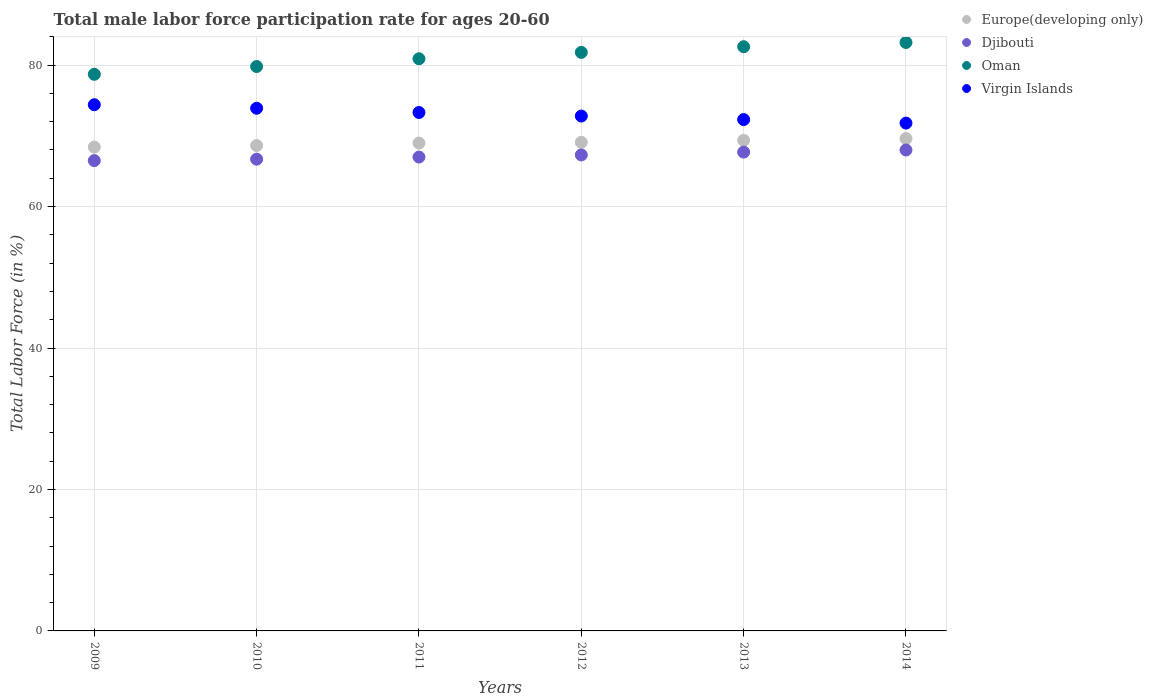What is the male labor force participation rate in Europe(developing only) in 2009?
Your answer should be compact. 68.41. Across all years, what is the minimum male labor force participation rate in Virgin Islands?
Keep it short and to the point. 71.8. What is the total male labor force participation rate in Virgin Islands in the graph?
Offer a very short reply. 438.5. What is the difference between the male labor force participation rate in Europe(developing only) in 2011 and that in 2014?
Give a very brief answer. -0.63. What is the difference between the male labor force participation rate in Virgin Islands in 2011 and the male labor force participation rate in Europe(developing only) in 2009?
Ensure brevity in your answer.  4.89. What is the average male labor force participation rate in Virgin Islands per year?
Provide a short and direct response. 73.08. In the year 2011, what is the difference between the male labor force participation rate in Virgin Islands and male labor force participation rate in Europe(developing only)?
Your answer should be compact. 4.32. In how many years, is the male labor force participation rate in Oman greater than 36 %?
Provide a succinct answer. 6. What is the ratio of the male labor force participation rate in Europe(developing only) in 2012 to that in 2014?
Your answer should be very brief. 0.99. Is the difference between the male labor force participation rate in Virgin Islands in 2012 and 2014 greater than the difference between the male labor force participation rate in Europe(developing only) in 2012 and 2014?
Provide a succinct answer. Yes. What is the difference between the highest and the second highest male labor force participation rate in Europe(developing only)?
Your answer should be very brief. 0.25. Does the male labor force participation rate in Virgin Islands monotonically increase over the years?
Ensure brevity in your answer.  No. Is the male labor force participation rate in Europe(developing only) strictly less than the male labor force participation rate in Oman over the years?
Give a very brief answer. Yes. What is the difference between two consecutive major ticks on the Y-axis?
Ensure brevity in your answer.  20. Are the values on the major ticks of Y-axis written in scientific E-notation?
Provide a succinct answer. No. Does the graph contain any zero values?
Your response must be concise. No. Does the graph contain grids?
Keep it short and to the point. Yes. Where does the legend appear in the graph?
Your answer should be compact. Top right. What is the title of the graph?
Ensure brevity in your answer.  Total male labor force participation rate for ages 20-60. What is the label or title of the X-axis?
Your answer should be very brief. Years. What is the Total Labor Force (in %) of Europe(developing only) in 2009?
Keep it short and to the point. 68.41. What is the Total Labor Force (in %) in Djibouti in 2009?
Give a very brief answer. 66.5. What is the Total Labor Force (in %) in Oman in 2009?
Give a very brief answer. 78.7. What is the Total Labor Force (in %) of Virgin Islands in 2009?
Provide a succinct answer. 74.4. What is the Total Labor Force (in %) in Europe(developing only) in 2010?
Provide a short and direct response. 68.63. What is the Total Labor Force (in %) in Djibouti in 2010?
Make the answer very short. 66.7. What is the Total Labor Force (in %) of Oman in 2010?
Your answer should be compact. 79.8. What is the Total Labor Force (in %) of Virgin Islands in 2010?
Your response must be concise. 73.9. What is the Total Labor Force (in %) of Europe(developing only) in 2011?
Your response must be concise. 68.98. What is the Total Labor Force (in %) in Oman in 2011?
Provide a short and direct response. 80.9. What is the Total Labor Force (in %) of Virgin Islands in 2011?
Offer a very short reply. 73.3. What is the Total Labor Force (in %) of Europe(developing only) in 2012?
Provide a succinct answer. 69.09. What is the Total Labor Force (in %) of Djibouti in 2012?
Provide a succinct answer. 67.3. What is the Total Labor Force (in %) of Oman in 2012?
Ensure brevity in your answer.  81.8. What is the Total Labor Force (in %) in Virgin Islands in 2012?
Your answer should be compact. 72.8. What is the Total Labor Force (in %) in Europe(developing only) in 2013?
Offer a terse response. 69.37. What is the Total Labor Force (in %) in Djibouti in 2013?
Offer a terse response. 67.7. What is the Total Labor Force (in %) of Oman in 2013?
Offer a terse response. 82.6. What is the Total Labor Force (in %) in Virgin Islands in 2013?
Offer a terse response. 72.3. What is the Total Labor Force (in %) of Europe(developing only) in 2014?
Make the answer very short. 69.61. What is the Total Labor Force (in %) of Djibouti in 2014?
Offer a terse response. 68. What is the Total Labor Force (in %) in Oman in 2014?
Give a very brief answer. 83.2. What is the Total Labor Force (in %) of Virgin Islands in 2014?
Provide a succinct answer. 71.8. Across all years, what is the maximum Total Labor Force (in %) in Europe(developing only)?
Your answer should be compact. 69.61. Across all years, what is the maximum Total Labor Force (in %) of Djibouti?
Your response must be concise. 68. Across all years, what is the maximum Total Labor Force (in %) of Oman?
Offer a very short reply. 83.2. Across all years, what is the maximum Total Labor Force (in %) in Virgin Islands?
Your response must be concise. 74.4. Across all years, what is the minimum Total Labor Force (in %) of Europe(developing only)?
Offer a very short reply. 68.41. Across all years, what is the minimum Total Labor Force (in %) in Djibouti?
Provide a short and direct response. 66.5. Across all years, what is the minimum Total Labor Force (in %) in Oman?
Give a very brief answer. 78.7. Across all years, what is the minimum Total Labor Force (in %) in Virgin Islands?
Your response must be concise. 71.8. What is the total Total Labor Force (in %) in Europe(developing only) in the graph?
Keep it short and to the point. 414.09. What is the total Total Labor Force (in %) of Djibouti in the graph?
Offer a very short reply. 403.2. What is the total Total Labor Force (in %) in Oman in the graph?
Your answer should be compact. 487. What is the total Total Labor Force (in %) in Virgin Islands in the graph?
Your response must be concise. 438.5. What is the difference between the Total Labor Force (in %) of Europe(developing only) in 2009 and that in 2010?
Provide a succinct answer. -0.22. What is the difference between the Total Labor Force (in %) in Djibouti in 2009 and that in 2010?
Ensure brevity in your answer.  -0.2. What is the difference between the Total Labor Force (in %) in Oman in 2009 and that in 2010?
Provide a succinct answer. -1.1. What is the difference between the Total Labor Force (in %) of Virgin Islands in 2009 and that in 2010?
Your answer should be very brief. 0.5. What is the difference between the Total Labor Force (in %) of Europe(developing only) in 2009 and that in 2011?
Offer a very short reply. -0.57. What is the difference between the Total Labor Force (in %) of Djibouti in 2009 and that in 2011?
Offer a very short reply. -0.5. What is the difference between the Total Labor Force (in %) of Europe(developing only) in 2009 and that in 2012?
Your answer should be very brief. -0.68. What is the difference between the Total Labor Force (in %) of Oman in 2009 and that in 2012?
Offer a very short reply. -3.1. What is the difference between the Total Labor Force (in %) in Virgin Islands in 2009 and that in 2012?
Your response must be concise. 1.6. What is the difference between the Total Labor Force (in %) in Europe(developing only) in 2009 and that in 2013?
Offer a terse response. -0.96. What is the difference between the Total Labor Force (in %) in Virgin Islands in 2009 and that in 2013?
Make the answer very short. 2.1. What is the difference between the Total Labor Force (in %) in Europe(developing only) in 2009 and that in 2014?
Your response must be concise. -1.21. What is the difference between the Total Labor Force (in %) of Djibouti in 2009 and that in 2014?
Ensure brevity in your answer.  -1.5. What is the difference between the Total Labor Force (in %) in Oman in 2009 and that in 2014?
Provide a short and direct response. -4.5. What is the difference between the Total Labor Force (in %) in Virgin Islands in 2009 and that in 2014?
Ensure brevity in your answer.  2.6. What is the difference between the Total Labor Force (in %) in Europe(developing only) in 2010 and that in 2011?
Give a very brief answer. -0.35. What is the difference between the Total Labor Force (in %) in Oman in 2010 and that in 2011?
Provide a succinct answer. -1.1. What is the difference between the Total Labor Force (in %) in Virgin Islands in 2010 and that in 2011?
Ensure brevity in your answer.  0.6. What is the difference between the Total Labor Force (in %) in Europe(developing only) in 2010 and that in 2012?
Make the answer very short. -0.46. What is the difference between the Total Labor Force (in %) in Virgin Islands in 2010 and that in 2012?
Keep it short and to the point. 1.1. What is the difference between the Total Labor Force (in %) of Europe(developing only) in 2010 and that in 2013?
Ensure brevity in your answer.  -0.74. What is the difference between the Total Labor Force (in %) of Djibouti in 2010 and that in 2013?
Your answer should be compact. -1. What is the difference between the Total Labor Force (in %) in Europe(developing only) in 2010 and that in 2014?
Your answer should be very brief. -0.99. What is the difference between the Total Labor Force (in %) of Djibouti in 2010 and that in 2014?
Provide a short and direct response. -1.3. What is the difference between the Total Labor Force (in %) of Europe(developing only) in 2011 and that in 2012?
Keep it short and to the point. -0.1. What is the difference between the Total Labor Force (in %) of Djibouti in 2011 and that in 2012?
Make the answer very short. -0.3. What is the difference between the Total Labor Force (in %) of Europe(developing only) in 2011 and that in 2013?
Make the answer very short. -0.39. What is the difference between the Total Labor Force (in %) in Europe(developing only) in 2011 and that in 2014?
Keep it short and to the point. -0.63. What is the difference between the Total Labor Force (in %) of Oman in 2011 and that in 2014?
Offer a terse response. -2.3. What is the difference between the Total Labor Force (in %) of Virgin Islands in 2011 and that in 2014?
Keep it short and to the point. 1.5. What is the difference between the Total Labor Force (in %) of Europe(developing only) in 2012 and that in 2013?
Give a very brief answer. -0.28. What is the difference between the Total Labor Force (in %) in Djibouti in 2012 and that in 2013?
Offer a very short reply. -0.4. What is the difference between the Total Labor Force (in %) of Oman in 2012 and that in 2013?
Make the answer very short. -0.8. What is the difference between the Total Labor Force (in %) of Europe(developing only) in 2012 and that in 2014?
Make the answer very short. -0.53. What is the difference between the Total Labor Force (in %) in Djibouti in 2012 and that in 2014?
Provide a short and direct response. -0.7. What is the difference between the Total Labor Force (in %) of Europe(developing only) in 2013 and that in 2014?
Provide a short and direct response. -0.25. What is the difference between the Total Labor Force (in %) of Oman in 2013 and that in 2014?
Your answer should be very brief. -0.6. What is the difference between the Total Labor Force (in %) of Virgin Islands in 2013 and that in 2014?
Offer a very short reply. 0.5. What is the difference between the Total Labor Force (in %) of Europe(developing only) in 2009 and the Total Labor Force (in %) of Djibouti in 2010?
Provide a succinct answer. 1.71. What is the difference between the Total Labor Force (in %) in Europe(developing only) in 2009 and the Total Labor Force (in %) in Oman in 2010?
Offer a very short reply. -11.39. What is the difference between the Total Labor Force (in %) in Europe(developing only) in 2009 and the Total Labor Force (in %) in Virgin Islands in 2010?
Make the answer very short. -5.49. What is the difference between the Total Labor Force (in %) of Europe(developing only) in 2009 and the Total Labor Force (in %) of Djibouti in 2011?
Keep it short and to the point. 1.41. What is the difference between the Total Labor Force (in %) in Europe(developing only) in 2009 and the Total Labor Force (in %) in Oman in 2011?
Provide a short and direct response. -12.49. What is the difference between the Total Labor Force (in %) of Europe(developing only) in 2009 and the Total Labor Force (in %) of Virgin Islands in 2011?
Provide a succinct answer. -4.89. What is the difference between the Total Labor Force (in %) of Djibouti in 2009 and the Total Labor Force (in %) of Oman in 2011?
Provide a short and direct response. -14.4. What is the difference between the Total Labor Force (in %) in Djibouti in 2009 and the Total Labor Force (in %) in Virgin Islands in 2011?
Provide a short and direct response. -6.8. What is the difference between the Total Labor Force (in %) of Oman in 2009 and the Total Labor Force (in %) of Virgin Islands in 2011?
Your answer should be compact. 5.4. What is the difference between the Total Labor Force (in %) of Europe(developing only) in 2009 and the Total Labor Force (in %) of Djibouti in 2012?
Give a very brief answer. 1.11. What is the difference between the Total Labor Force (in %) in Europe(developing only) in 2009 and the Total Labor Force (in %) in Oman in 2012?
Your answer should be compact. -13.39. What is the difference between the Total Labor Force (in %) of Europe(developing only) in 2009 and the Total Labor Force (in %) of Virgin Islands in 2012?
Ensure brevity in your answer.  -4.39. What is the difference between the Total Labor Force (in %) of Djibouti in 2009 and the Total Labor Force (in %) of Oman in 2012?
Give a very brief answer. -15.3. What is the difference between the Total Labor Force (in %) in Europe(developing only) in 2009 and the Total Labor Force (in %) in Djibouti in 2013?
Offer a terse response. 0.71. What is the difference between the Total Labor Force (in %) in Europe(developing only) in 2009 and the Total Labor Force (in %) in Oman in 2013?
Make the answer very short. -14.19. What is the difference between the Total Labor Force (in %) in Europe(developing only) in 2009 and the Total Labor Force (in %) in Virgin Islands in 2013?
Provide a succinct answer. -3.89. What is the difference between the Total Labor Force (in %) of Djibouti in 2009 and the Total Labor Force (in %) of Oman in 2013?
Your answer should be very brief. -16.1. What is the difference between the Total Labor Force (in %) of Oman in 2009 and the Total Labor Force (in %) of Virgin Islands in 2013?
Ensure brevity in your answer.  6.4. What is the difference between the Total Labor Force (in %) of Europe(developing only) in 2009 and the Total Labor Force (in %) of Djibouti in 2014?
Give a very brief answer. 0.41. What is the difference between the Total Labor Force (in %) of Europe(developing only) in 2009 and the Total Labor Force (in %) of Oman in 2014?
Offer a terse response. -14.79. What is the difference between the Total Labor Force (in %) in Europe(developing only) in 2009 and the Total Labor Force (in %) in Virgin Islands in 2014?
Give a very brief answer. -3.39. What is the difference between the Total Labor Force (in %) of Djibouti in 2009 and the Total Labor Force (in %) of Oman in 2014?
Keep it short and to the point. -16.7. What is the difference between the Total Labor Force (in %) in Oman in 2009 and the Total Labor Force (in %) in Virgin Islands in 2014?
Offer a very short reply. 6.9. What is the difference between the Total Labor Force (in %) in Europe(developing only) in 2010 and the Total Labor Force (in %) in Djibouti in 2011?
Ensure brevity in your answer.  1.63. What is the difference between the Total Labor Force (in %) of Europe(developing only) in 2010 and the Total Labor Force (in %) of Oman in 2011?
Your answer should be compact. -12.27. What is the difference between the Total Labor Force (in %) of Europe(developing only) in 2010 and the Total Labor Force (in %) of Virgin Islands in 2011?
Make the answer very short. -4.67. What is the difference between the Total Labor Force (in %) in Djibouti in 2010 and the Total Labor Force (in %) in Virgin Islands in 2011?
Your answer should be compact. -6.6. What is the difference between the Total Labor Force (in %) in Europe(developing only) in 2010 and the Total Labor Force (in %) in Djibouti in 2012?
Offer a terse response. 1.33. What is the difference between the Total Labor Force (in %) of Europe(developing only) in 2010 and the Total Labor Force (in %) of Oman in 2012?
Provide a short and direct response. -13.17. What is the difference between the Total Labor Force (in %) in Europe(developing only) in 2010 and the Total Labor Force (in %) in Virgin Islands in 2012?
Ensure brevity in your answer.  -4.17. What is the difference between the Total Labor Force (in %) of Djibouti in 2010 and the Total Labor Force (in %) of Oman in 2012?
Your response must be concise. -15.1. What is the difference between the Total Labor Force (in %) of Oman in 2010 and the Total Labor Force (in %) of Virgin Islands in 2012?
Your answer should be compact. 7. What is the difference between the Total Labor Force (in %) in Europe(developing only) in 2010 and the Total Labor Force (in %) in Djibouti in 2013?
Provide a short and direct response. 0.93. What is the difference between the Total Labor Force (in %) in Europe(developing only) in 2010 and the Total Labor Force (in %) in Oman in 2013?
Make the answer very short. -13.97. What is the difference between the Total Labor Force (in %) of Europe(developing only) in 2010 and the Total Labor Force (in %) of Virgin Islands in 2013?
Your answer should be compact. -3.67. What is the difference between the Total Labor Force (in %) in Djibouti in 2010 and the Total Labor Force (in %) in Oman in 2013?
Keep it short and to the point. -15.9. What is the difference between the Total Labor Force (in %) of Oman in 2010 and the Total Labor Force (in %) of Virgin Islands in 2013?
Offer a very short reply. 7.5. What is the difference between the Total Labor Force (in %) of Europe(developing only) in 2010 and the Total Labor Force (in %) of Djibouti in 2014?
Your response must be concise. 0.63. What is the difference between the Total Labor Force (in %) of Europe(developing only) in 2010 and the Total Labor Force (in %) of Oman in 2014?
Your response must be concise. -14.57. What is the difference between the Total Labor Force (in %) in Europe(developing only) in 2010 and the Total Labor Force (in %) in Virgin Islands in 2014?
Ensure brevity in your answer.  -3.17. What is the difference between the Total Labor Force (in %) of Djibouti in 2010 and the Total Labor Force (in %) of Oman in 2014?
Provide a succinct answer. -16.5. What is the difference between the Total Labor Force (in %) in Djibouti in 2010 and the Total Labor Force (in %) in Virgin Islands in 2014?
Keep it short and to the point. -5.1. What is the difference between the Total Labor Force (in %) of Oman in 2010 and the Total Labor Force (in %) of Virgin Islands in 2014?
Your answer should be compact. 8. What is the difference between the Total Labor Force (in %) of Europe(developing only) in 2011 and the Total Labor Force (in %) of Djibouti in 2012?
Your answer should be very brief. 1.68. What is the difference between the Total Labor Force (in %) in Europe(developing only) in 2011 and the Total Labor Force (in %) in Oman in 2012?
Your answer should be very brief. -12.82. What is the difference between the Total Labor Force (in %) of Europe(developing only) in 2011 and the Total Labor Force (in %) of Virgin Islands in 2012?
Ensure brevity in your answer.  -3.82. What is the difference between the Total Labor Force (in %) in Djibouti in 2011 and the Total Labor Force (in %) in Oman in 2012?
Give a very brief answer. -14.8. What is the difference between the Total Labor Force (in %) of Djibouti in 2011 and the Total Labor Force (in %) of Virgin Islands in 2012?
Ensure brevity in your answer.  -5.8. What is the difference between the Total Labor Force (in %) in Oman in 2011 and the Total Labor Force (in %) in Virgin Islands in 2012?
Give a very brief answer. 8.1. What is the difference between the Total Labor Force (in %) of Europe(developing only) in 2011 and the Total Labor Force (in %) of Djibouti in 2013?
Offer a very short reply. 1.28. What is the difference between the Total Labor Force (in %) of Europe(developing only) in 2011 and the Total Labor Force (in %) of Oman in 2013?
Give a very brief answer. -13.62. What is the difference between the Total Labor Force (in %) of Europe(developing only) in 2011 and the Total Labor Force (in %) of Virgin Islands in 2013?
Give a very brief answer. -3.32. What is the difference between the Total Labor Force (in %) of Djibouti in 2011 and the Total Labor Force (in %) of Oman in 2013?
Your response must be concise. -15.6. What is the difference between the Total Labor Force (in %) of Europe(developing only) in 2011 and the Total Labor Force (in %) of Djibouti in 2014?
Your response must be concise. 0.98. What is the difference between the Total Labor Force (in %) in Europe(developing only) in 2011 and the Total Labor Force (in %) in Oman in 2014?
Your answer should be very brief. -14.22. What is the difference between the Total Labor Force (in %) of Europe(developing only) in 2011 and the Total Labor Force (in %) of Virgin Islands in 2014?
Your answer should be compact. -2.82. What is the difference between the Total Labor Force (in %) of Djibouti in 2011 and the Total Labor Force (in %) of Oman in 2014?
Your answer should be compact. -16.2. What is the difference between the Total Labor Force (in %) in Djibouti in 2011 and the Total Labor Force (in %) in Virgin Islands in 2014?
Offer a terse response. -4.8. What is the difference between the Total Labor Force (in %) in Oman in 2011 and the Total Labor Force (in %) in Virgin Islands in 2014?
Give a very brief answer. 9.1. What is the difference between the Total Labor Force (in %) in Europe(developing only) in 2012 and the Total Labor Force (in %) in Djibouti in 2013?
Give a very brief answer. 1.39. What is the difference between the Total Labor Force (in %) of Europe(developing only) in 2012 and the Total Labor Force (in %) of Oman in 2013?
Keep it short and to the point. -13.51. What is the difference between the Total Labor Force (in %) in Europe(developing only) in 2012 and the Total Labor Force (in %) in Virgin Islands in 2013?
Make the answer very short. -3.21. What is the difference between the Total Labor Force (in %) in Djibouti in 2012 and the Total Labor Force (in %) in Oman in 2013?
Your answer should be compact. -15.3. What is the difference between the Total Labor Force (in %) of Djibouti in 2012 and the Total Labor Force (in %) of Virgin Islands in 2013?
Give a very brief answer. -5. What is the difference between the Total Labor Force (in %) of Europe(developing only) in 2012 and the Total Labor Force (in %) of Djibouti in 2014?
Ensure brevity in your answer.  1.09. What is the difference between the Total Labor Force (in %) in Europe(developing only) in 2012 and the Total Labor Force (in %) in Oman in 2014?
Offer a terse response. -14.11. What is the difference between the Total Labor Force (in %) in Europe(developing only) in 2012 and the Total Labor Force (in %) in Virgin Islands in 2014?
Your response must be concise. -2.71. What is the difference between the Total Labor Force (in %) in Djibouti in 2012 and the Total Labor Force (in %) in Oman in 2014?
Provide a short and direct response. -15.9. What is the difference between the Total Labor Force (in %) in Europe(developing only) in 2013 and the Total Labor Force (in %) in Djibouti in 2014?
Your answer should be compact. 1.37. What is the difference between the Total Labor Force (in %) of Europe(developing only) in 2013 and the Total Labor Force (in %) of Oman in 2014?
Your answer should be compact. -13.83. What is the difference between the Total Labor Force (in %) in Europe(developing only) in 2013 and the Total Labor Force (in %) in Virgin Islands in 2014?
Your answer should be very brief. -2.43. What is the difference between the Total Labor Force (in %) in Djibouti in 2013 and the Total Labor Force (in %) in Oman in 2014?
Provide a short and direct response. -15.5. What is the difference between the Total Labor Force (in %) in Djibouti in 2013 and the Total Labor Force (in %) in Virgin Islands in 2014?
Provide a succinct answer. -4.1. What is the average Total Labor Force (in %) in Europe(developing only) per year?
Provide a short and direct response. 69.02. What is the average Total Labor Force (in %) of Djibouti per year?
Your answer should be very brief. 67.2. What is the average Total Labor Force (in %) of Oman per year?
Your response must be concise. 81.17. What is the average Total Labor Force (in %) in Virgin Islands per year?
Keep it short and to the point. 73.08. In the year 2009, what is the difference between the Total Labor Force (in %) of Europe(developing only) and Total Labor Force (in %) of Djibouti?
Give a very brief answer. 1.91. In the year 2009, what is the difference between the Total Labor Force (in %) of Europe(developing only) and Total Labor Force (in %) of Oman?
Ensure brevity in your answer.  -10.29. In the year 2009, what is the difference between the Total Labor Force (in %) of Europe(developing only) and Total Labor Force (in %) of Virgin Islands?
Your answer should be compact. -5.99. In the year 2009, what is the difference between the Total Labor Force (in %) of Djibouti and Total Labor Force (in %) of Oman?
Give a very brief answer. -12.2. In the year 2009, what is the difference between the Total Labor Force (in %) in Djibouti and Total Labor Force (in %) in Virgin Islands?
Ensure brevity in your answer.  -7.9. In the year 2010, what is the difference between the Total Labor Force (in %) of Europe(developing only) and Total Labor Force (in %) of Djibouti?
Your response must be concise. 1.93. In the year 2010, what is the difference between the Total Labor Force (in %) in Europe(developing only) and Total Labor Force (in %) in Oman?
Offer a very short reply. -11.17. In the year 2010, what is the difference between the Total Labor Force (in %) in Europe(developing only) and Total Labor Force (in %) in Virgin Islands?
Make the answer very short. -5.27. In the year 2010, what is the difference between the Total Labor Force (in %) in Djibouti and Total Labor Force (in %) in Virgin Islands?
Make the answer very short. -7.2. In the year 2011, what is the difference between the Total Labor Force (in %) of Europe(developing only) and Total Labor Force (in %) of Djibouti?
Offer a very short reply. 1.98. In the year 2011, what is the difference between the Total Labor Force (in %) in Europe(developing only) and Total Labor Force (in %) in Oman?
Provide a short and direct response. -11.92. In the year 2011, what is the difference between the Total Labor Force (in %) in Europe(developing only) and Total Labor Force (in %) in Virgin Islands?
Offer a terse response. -4.32. In the year 2011, what is the difference between the Total Labor Force (in %) of Djibouti and Total Labor Force (in %) of Oman?
Keep it short and to the point. -13.9. In the year 2012, what is the difference between the Total Labor Force (in %) in Europe(developing only) and Total Labor Force (in %) in Djibouti?
Your response must be concise. 1.79. In the year 2012, what is the difference between the Total Labor Force (in %) in Europe(developing only) and Total Labor Force (in %) in Oman?
Offer a terse response. -12.71. In the year 2012, what is the difference between the Total Labor Force (in %) of Europe(developing only) and Total Labor Force (in %) of Virgin Islands?
Make the answer very short. -3.71. In the year 2012, what is the difference between the Total Labor Force (in %) of Djibouti and Total Labor Force (in %) of Oman?
Offer a very short reply. -14.5. In the year 2012, what is the difference between the Total Labor Force (in %) of Djibouti and Total Labor Force (in %) of Virgin Islands?
Give a very brief answer. -5.5. In the year 2012, what is the difference between the Total Labor Force (in %) of Oman and Total Labor Force (in %) of Virgin Islands?
Give a very brief answer. 9. In the year 2013, what is the difference between the Total Labor Force (in %) in Europe(developing only) and Total Labor Force (in %) in Djibouti?
Make the answer very short. 1.67. In the year 2013, what is the difference between the Total Labor Force (in %) of Europe(developing only) and Total Labor Force (in %) of Oman?
Keep it short and to the point. -13.23. In the year 2013, what is the difference between the Total Labor Force (in %) in Europe(developing only) and Total Labor Force (in %) in Virgin Islands?
Your answer should be compact. -2.93. In the year 2013, what is the difference between the Total Labor Force (in %) in Djibouti and Total Labor Force (in %) in Oman?
Provide a succinct answer. -14.9. In the year 2013, what is the difference between the Total Labor Force (in %) in Djibouti and Total Labor Force (in %) in Virgin Islands?
Offer a terse response. -4.6. In the year 2014, what is the difference between the Total Labor Force (in %) in Europe(developing only) and Total Labor Force (in %) in Djibouti?
Provide a short and direct response. 1.61. In the year 2014, what is the difference between the Total Labor Force (in %) of Europe(developing only) and Total Labor Force (in %) of Oman?
Offer a terse response. -13.59. In the year 2014, what is the difference between the Total Labor Force (in %) in Europe(developing only) and Total Labor Force (in %) in Virgin Islands?
Make the answer very short. -2.19. In the year 2014, what is the difference between the Total Labor Force (in %) of Djibouti and Total Labor Force (in %) of Oman?
Keep it short and to the point. -15.2. In the year 2014, what is the difference between the Total Labor Force (in %) of Djibouti and Total Labor Force (in %) of Virgin Islands?
Offer a terse response. -3.8. What is the ratio of the Total Labor Force (in %) in Oman in 2009 to that in 2010?
Your response must be concise. 0.99. What is the ratio of the Total Labor Force (in %) in Virgin Islands in 2009 to that in 2010?
Keep it short and to the point. 1.01. What is the ratio of the Total Labor Force (in %) of Djibouti in 2009 to that in 2011?
Keep it short and to the point. 0.99. What is the ratio of the Total Labor Force (in %) in Oman in 2009 to that in 2011?
Keep it short and to the point. 0.97. What is the ratio of the Total Labor Force (in %) of Virgin Islands in 2009 to that in 2011?
Make the answer very short. 1.01. What is the ratio of the Total Labor Force (in %) of Europe(developing only) in 2009 to that in 2012?
Offer a very short reply. 0.99. What is the ratio of the Total Labor Force (in %) of Oman in 2009 to that in 2012?
Keep it short and to the point. 0.96. What is the ratio of the Total Labor Force (in %) of Europe(developing only) in 2009 to that in 2013?
Offer a terse response. 0.99. What is the ratio of the Total Labor Force (in %) of Djibouti in 2009 to that in 2013?
Offer a very short reply. 0.98. What is the ratio of the Total Labor Force (in %) of Oman in 2009 to that in 2013?
Offer a terse response. 0.95. What is the ratio of the Total Labor Force (in %) of Europe(developing only) in 2009 to that in 2014?
Make the answer very short. 0.98. What is the ratio of the Total Labor Force (in %) of Djibouti in 2009 to that in 2014?
Offer a very short reply. 0.98. What is the ratio of the Total Labor Force (in %) of Oman in 2009 to that in 2014?
Provide a succinct answer. 0.95. What is the ratio of the Total Labor Force (in %) in Virgin Islands in 2009 to that in 2014?
Ensure brevity in your answer.  1.04. What is the ratio of the Total Labor Force (in %) of Europe(developing only) in 2010 to that in 2011?
Your response must be concise. 0.99. What is the ratio of the Total Labor Force (in %) of Djibouti in 2010 to that in 2011?
Keep it short and to the point. 1. What is the ratio of the Total Labor Force (in %) in Oman in 2010 to that in 2011?
Your answer should be compact. 0.99. What is the ratio of the Total Labor Force (in %) of Virgin Islands in 2010 to that in 2011?
Give a very brief answer. 1.01. What is the ratio of the Total Labor Force (in %) in Oman in 2010 to that in 2012?
Ensure brevity in your answer.  0.98. What is the ratio of the Total Labor Force (in %) in Virgin Islands in 2010 to that in 2012?
Offer a very short reply. 1.02. What is the ratio of the Total Labor Force (in %) in Europe(developing only) in 2010 to that in 2013?
Ensure brevity in your answer.  0.99. What is the ratio of the Total Labor Force (in %) of Djibouti in 2010 to that in 2013?
Offer a very short reply. 0.99. What is the ratio of the Total Labor Force (in %) in Oman in 2010 to that in 2013?
Your answer should be compact. 0.97. What is the ratio of the Total Labor Force (in %) in Virgin Islands in 2010 to that in 2013?
Your answer should be compact. 1.02. What is the ratio of the Total Labor Force (in %) in Europe(developing only) in 2010 to that in 2014?
Provide a succinct answer. 0.99. What is the ratio of the Total Labor Force (in %) of Djibouti in 2010 to that in 2014?
Offer a terse response. 0.98. What is the ratio of the Total Labor Force (in %) in Oman in 2010 to that in 2014?
Provide a short and direct response. 0.96. What is the ratio of the Total Labor Force (in %) in Virgin Islands in 2010 to that in 2014?
Offer a very short reply. 1.03. What is the ratio of the Total Labor Force (in %) of Djibouti in 2011 to that in 2012?
Offer a terse response. 1. What is the ratio of the Total Labor Force (in %) of Oman in 2011 to that in 2012?
Your response must be concise. 0.99. What is the ratio of the Total Labor Force (in %) in Virgin Islands in 2011 to that in 2012?
Ensure brevity in your answer.  1.01. What is the ratio of the Total Labor Force (in %) in Europe(developing only) in 2011 to that in 2013?
Your response must be concise. 0.99. What is the ratio of the Total Labor Force (in %) in Oman in 2011 to that in 2013?
Give a very brief answer. 0.98. What is the ratio of the Total Labor Force (in %) of Virgin Islands in 2011 to that in 2013?
Keep it short and to the point. 1.01. What is the ratio of the Total Labor Force (in %) of Europe(developing only) in 2011 to that in 2014?
Offer a very short reply. 0.99. What is the ratio of the Total Labor Force (in %) of Djibouti in 2011 to that in 2014?
Ensure brevity in your answer.  0.99. What is the ratio of the Total Labor Force (in %) in Oman in 2011 to that in 2014?
Your answer should be compact. 0.97. What is the ratio of the Total Labor Force (in %) in Virgin Islands in 2011 to that in 2014?
Give a very brief answer. 1.02. What is the ratio of the Total Labor Force (in %) in Djibouti in 2012 to that in 2013?
Your response must be concise. 0.99. What is the ratio of the Total Labor Force (in %) of Oman in 2012 to that in 2013?
Your answer should be very brief. 0.99. What is the ratio of the Total Labor Force (in %) in Djibouti in 2012 to that in 2014?
Offer a terse response. 0.99. What is the ratio of the Total Labor Force (in %) of Oman in 2012 to that in 2014?
Provide a succinct answer. 0.98. What is the ratio of the Total Labor Force (in %) of Virgin Islands in 2012 to that in 2014?
Make the answer very short. 1.01. What is the ratio of the Total Labor Force (in %) in Europe(developing only) in 2013 to that in 2014?
Make the answer very short. 1. What is the ratio of the Total Labor Force (in %) of Oman in 2013 to that in 2014?
Make the answer very short. 0.99. What is the ratio of the Total Labor Force (in %) of Virgin Islands in 2013 to that in 2014?
Give a very brief answer. 1.01. What is the difference between the highest and the second highest Total Labor Force (in %) of Europe(developing only)?
Give a very brief answer. 0.25. What is the difference between the highest and the second highest Total Labor Force (in %) of Oman?
Provide a short and direct response. 0.6. What is the difference between the highest and the second highest Total Labor Force (in %) in Virgin Islands?
Keep it short and to the point. 0.5. What is the difference between the highest and the lowest Total Labor Force (in %) of Europe(developing only)?
Provide a short and direct response. 1.21. 